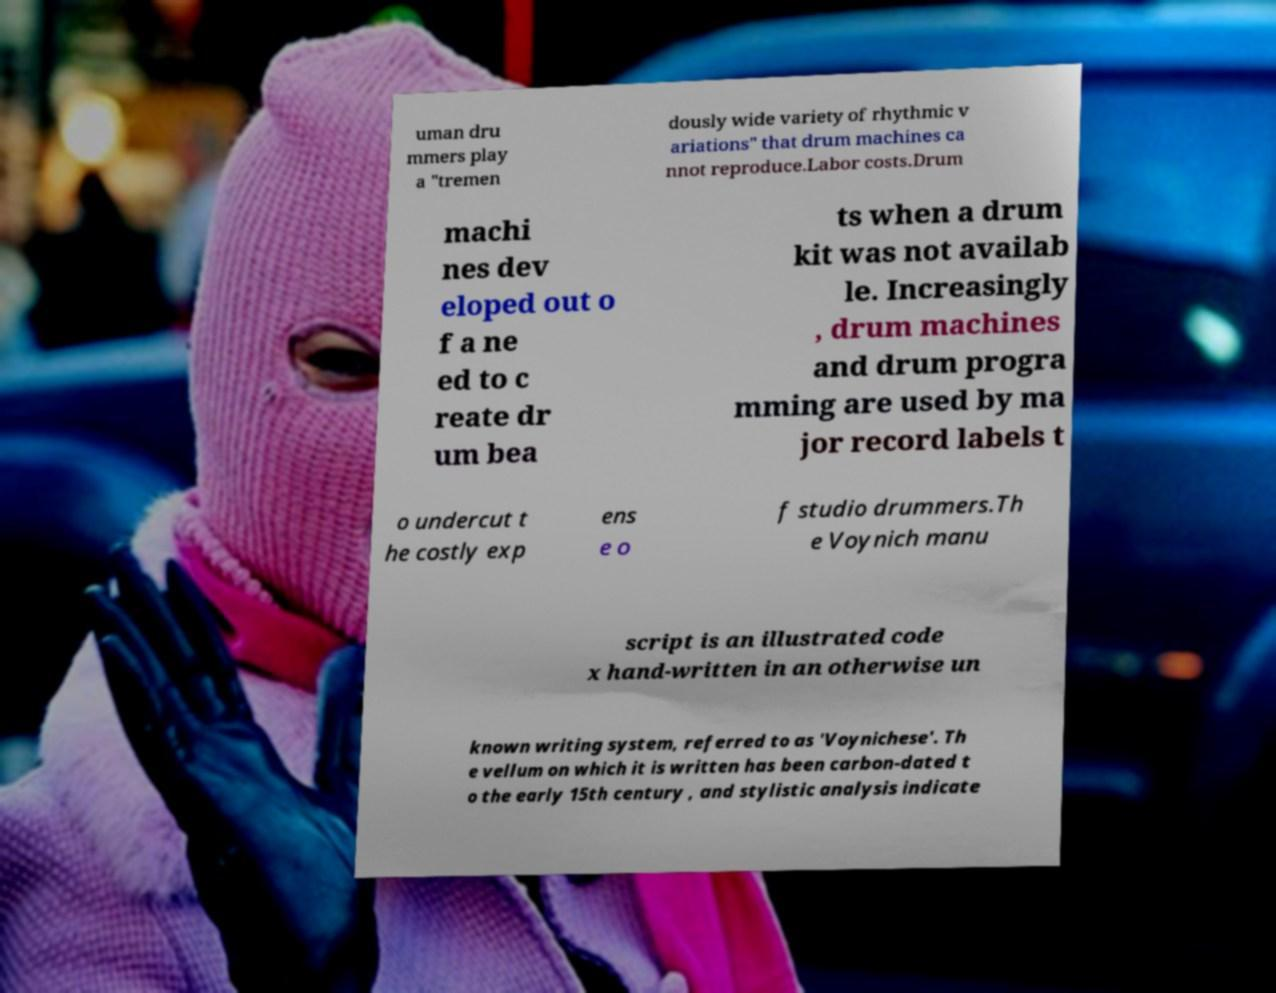Can you read and provide the text displayed in the image?This photo seems to have some interesting text. Can you extract and type it out for me? uman dru mmers play a "tremen dously wide variety of rhythmic v ariations" that drum machines ca nnot reproduce.Labor costs.Drum machi nes dev eloped out o f a ne ed to c reate dr um bea ts when a drum kit was not availab le. Increasingly , drum machines and drum progra mming are used by ma jor record labels t o undercut t he costly exp ens e o f studio drummers.Th e Voynich manu script is an illustrated code x hand-written in an otherwise un known writing system, referred to as 'Voynichese'. Th e vellum on which it is written has been carbon-dated t o the early 15th century , and stylistic analysis indicate 